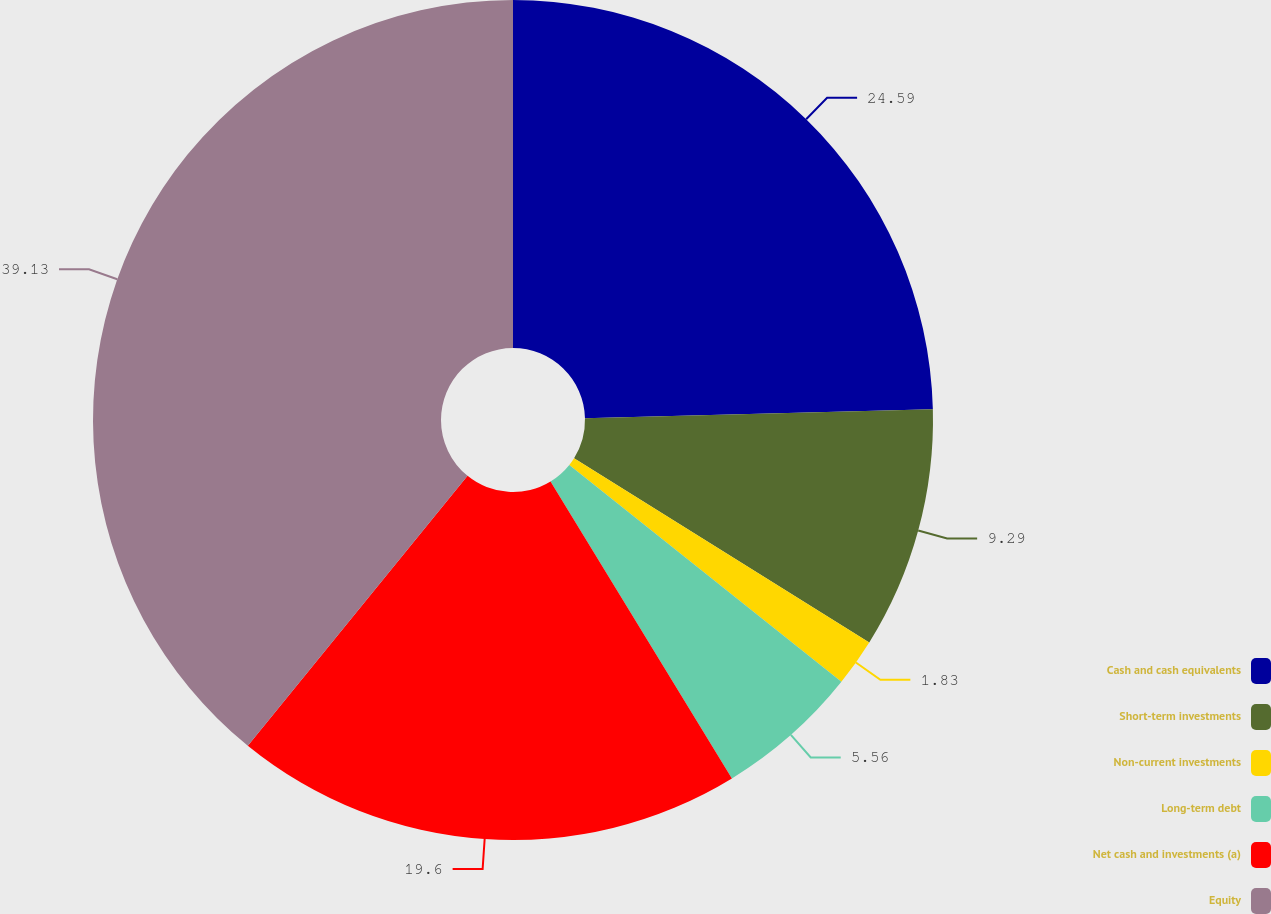<chart> <loc_0><loc_0><loc_500><loc_500><pie_chart><fcel>Cash and cash equivalents<fcel>Short-term investments<fcel>Non-current investments<fcel>Long-term debt<fcel>Net cash and investments (a)<fcel>Equity<nl><fcel>24.59%<fcel>9.29%<fcel>1.83%<fcel>5.56%<fcel>19.6%<fcel>39.12%<nl></chart> 